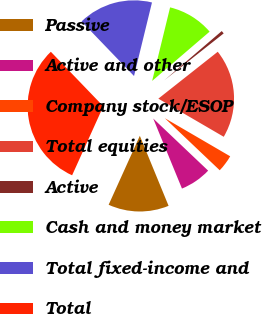Convert chart. <chart><loc_0><loc_0><loc_500><loc_500><pie_chart><fcel>Passive<fcel>Active and other<fcel>Company stock/ESOP<fcel>Total equities<fcel>Active<fcel>Cash and money market<fcel>Total fixed-income and<fcel>Total<nl><fcel>12.96%<fcel>6.72%<fcel>3.68%<fcel>19.04%<fcel>0.64%<fcel>9.91%<fcel>16.0%<fcel>31.05%<nl></chart> 